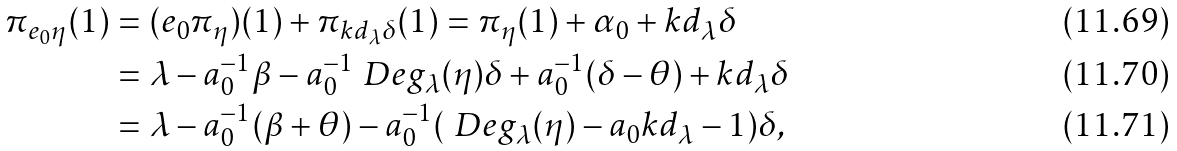Convert formula to latex. <formula><loc_0><loc_0><loc_500><loc_500>\pi _ { e _ { 0 } \eta } ( 1 ) & = ( e _ { 0 } \pi _ { \eta } ) ( 1 ) + \pi _ { k d _ { \lambda } \delta } ( 1 ) = \pi _ { \eta } ( 1 ) + \alpha _ { 0 } + k d _ { \lambda } \delta \\ & = \lambda - a _ { 0 } ^ { - 1 } \beta - a _ { 0 } ^ { - 1 } \ D e g _ { \lambda } ( \eta ) \delta + a _ { 0 } ^ { - 1 } ( \delta - \theta ) + k d _ { \lambda } \delta \\ & = \lambda - a _ { 0 } ^ { - 1 } ( \beta + \theta ) - a _ { 0 } ^ { - 1 } ( \ D e g _ { \lambda } ( \eta ) - a _ { 0 } k d _ { \lambda } - 1 ) \delta ,</formula> 